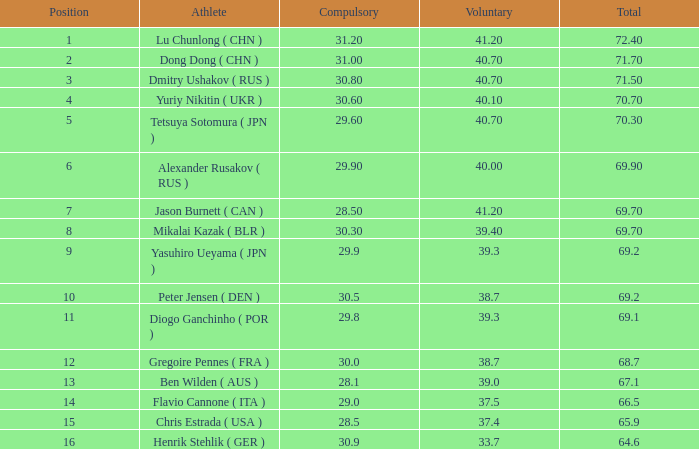7? None. 